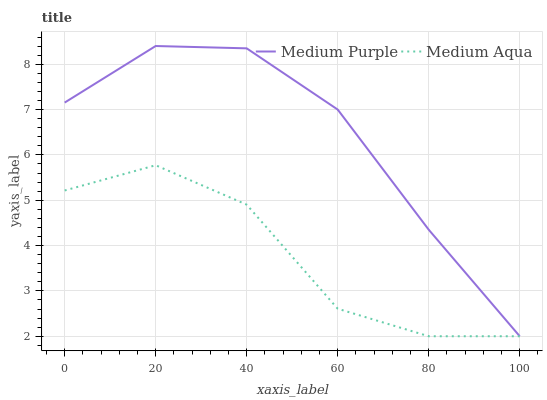Does Medium Aqua have the minimum area under the curve?
Answer yes or no. Yes. Does Medium Purple have the maximum area under the curve?
Answer yes or no. Yes. Does Medium Aqua have the maximum area under the curve?
Answer yes or no. No. Is Medium Purple the smoothest?
Answer yes or no. Yes. Is Medium Aqua the roughest?
Answer yes or no. Yes. Is Medium Aqua the smoothest?
Answer yes or no. No. Does Medium Purple have the lowest value?
Answer yes or no. Yes. Does Medium Purple have the highest value?
Answer yes or no. Yes. Does Medium Aqua have the highest value?
Answer yes or no. No. Does Medium Aqua intersect Medium Purple?
Answer yes or no. Yes. Is Medium Aqua less than Medium Purple?
Answer yes or no. No. Is Medium Aqua greater than Medium Purple?
Answer yes or no. No. 